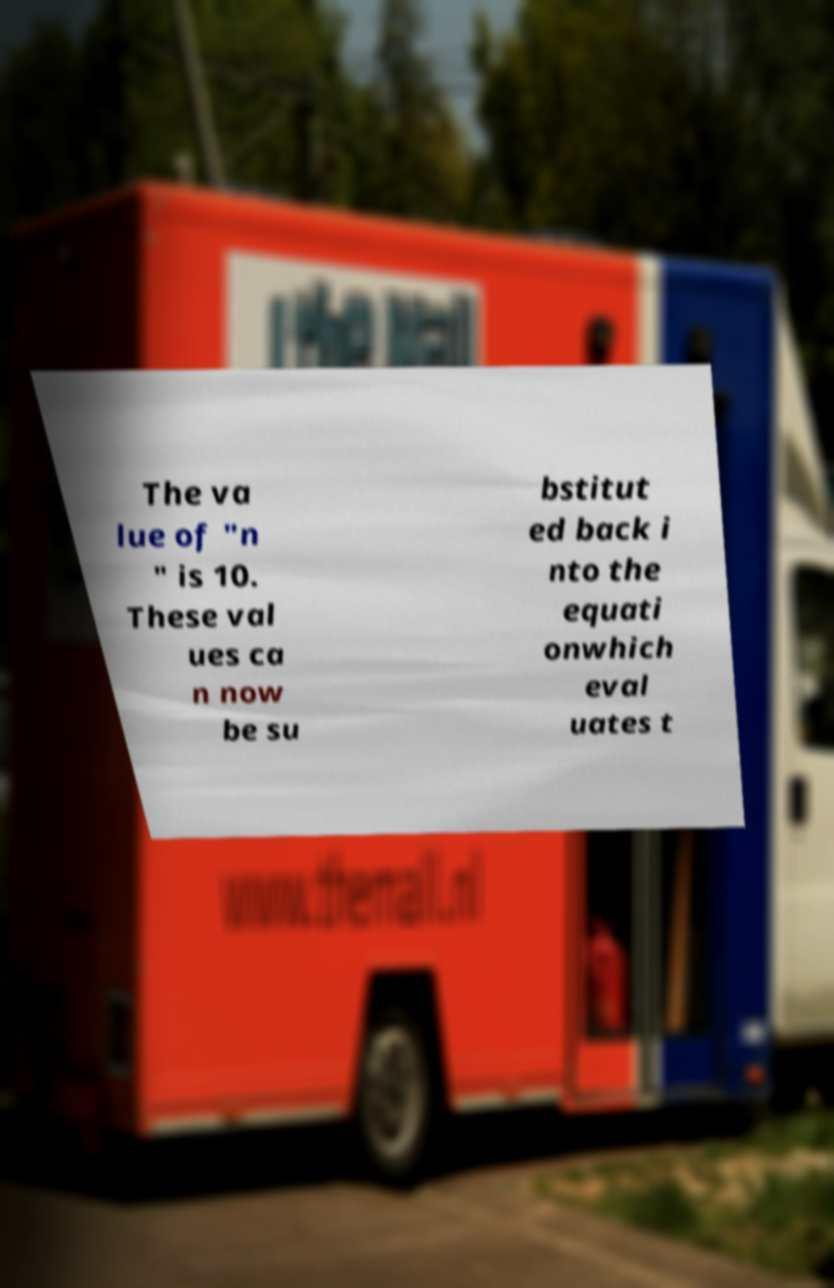There's text embedded in this image that I need extracted. Can you transcribe it verbatim? The va lue of "n " is 10. These val ues ca n now be su bstitut ed back i nto the equati onwhich eval uates t 